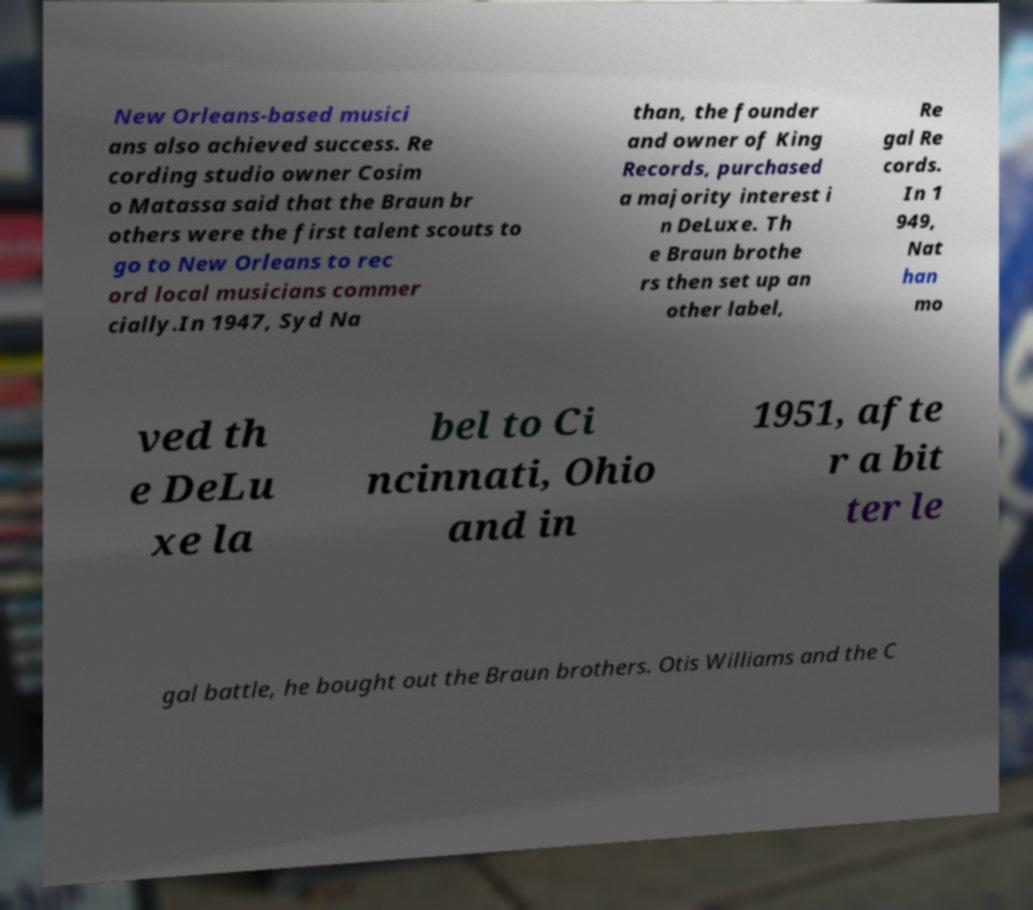Can you accurately transcribe the text from the provided image for me? New Orleans-based musici ans also achieved success. Re cording studio owner Cosim o Matassa said that the Braun br others were the first talent scouts to go to New Orleans to rec ord local musicians commer cially.In 1947, Syd Na than, the founder and owner of King Records, purchased a majority interest i n DeLuxe. Th e Braun brothe rs then set up an other label, Re gal Re cords. In 1 949, Nat han mo ved th e DeLu xe la bel to Ci ncinnati, Ohio and in 1951, afte r a bit ter le gal battle, he bought out the Braun brothers. Otis Williams and the C 